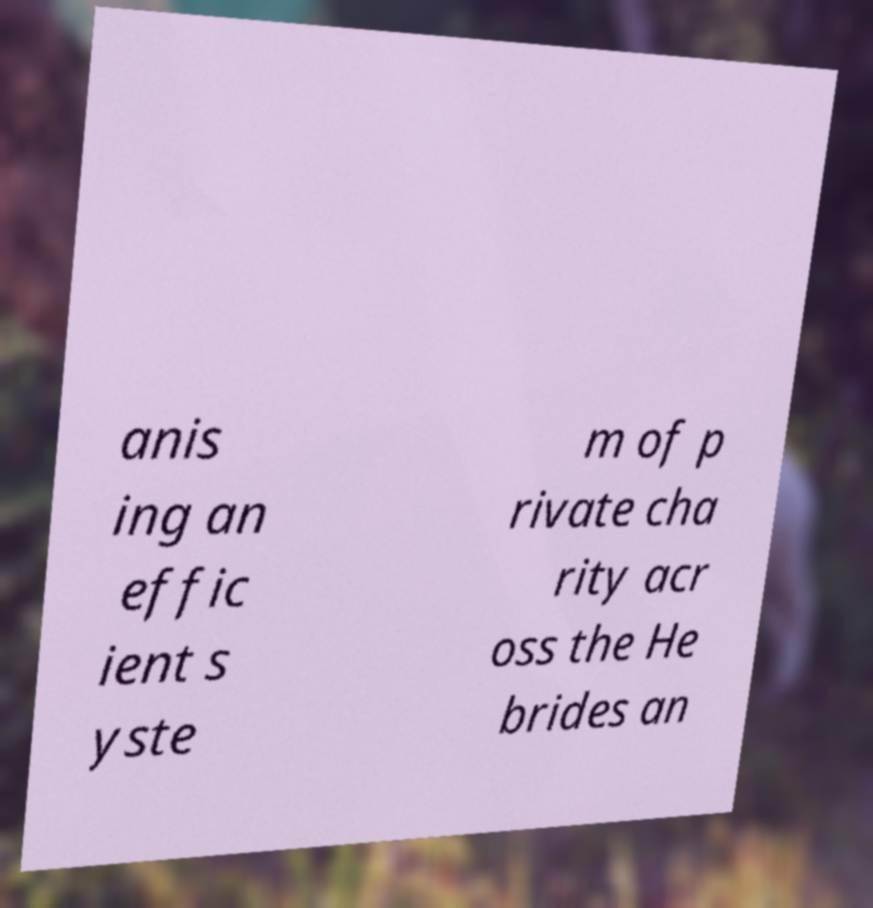What messages or text are displayed in this image? I need them in a readable, typed format. anis ing an effic ient s yste m of p rivate cha rity acr oss the He brides an 